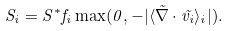Convert formula to latex. <formula><loc_0><loc_0><loc_500><loc_500>S _ { i } = S ^ { * } f _ { i } \max ( 0 , - | \langle \vec { \nabla } \cdot \vec { v _ { i } } \rangle _ { i } | ) .</formula> 